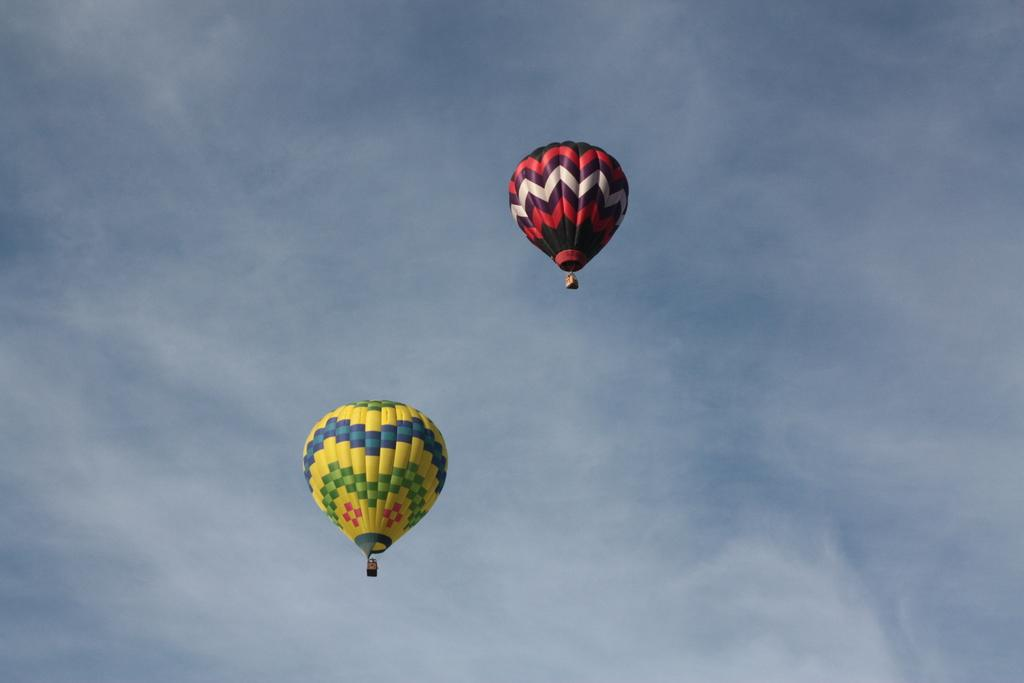What can be seen in the background of the image? The sky is visible in the image. What is happening in the sky? There are air balloons flying in the sky. What type of lawyer is present in the image? There is no lawyer present in the image; it only features the sky and air balloons. Can you tell me how many dogs are visible in the image? There are no dogs present in the image; it only features the sky and air balloons. 